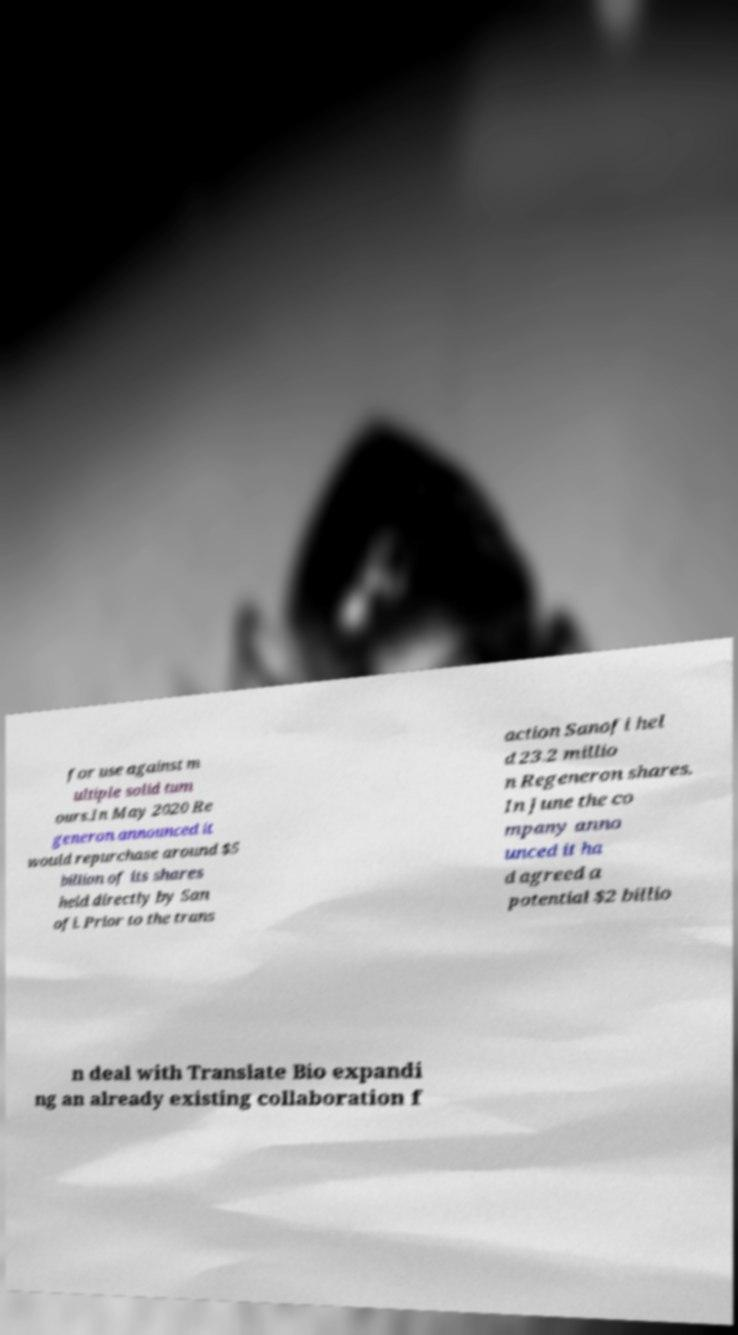Could you extract and type out the text from this image? for use against m ultiple solid tum ours.In May 2020 Re generon announced it would repurchase around $5 billion of its shares held directly by San ofi. Prior to the trans action Sanofi hel d 23.2 millio n Regeneron shares. In June the co mpany anno unced it ha d agreed a potential $2 billio n deal with Translate Bio expandi ng an already existing collaboration f 